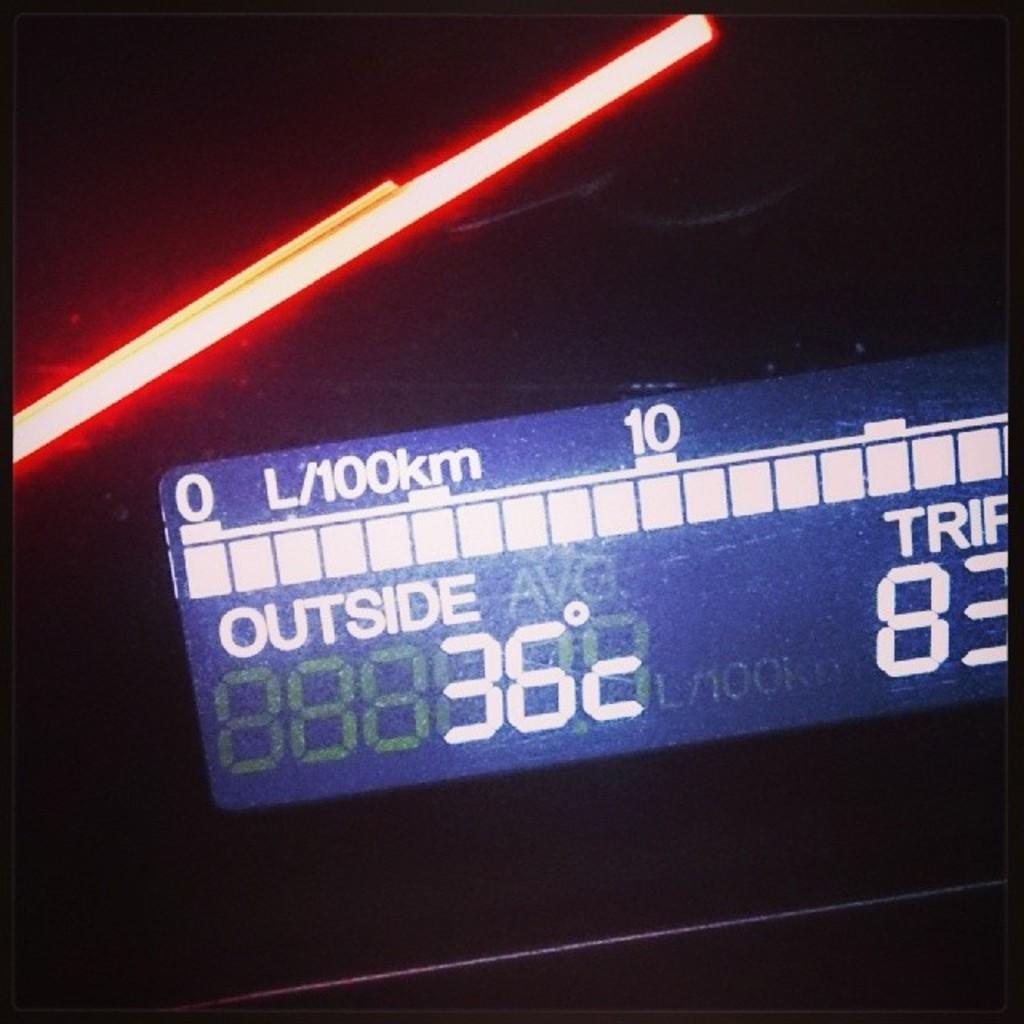What is the temperature outside?
Your answer should be very brief. 36c. That place must be quite hot?
Give a very brief answer. Yes. 